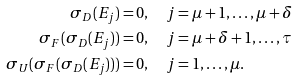<formula> <loc_0><loc_0><loc_500><loc_500>\sigma _ { D } ( E _ { j } ) & = 0 , \quad j = \mu + 1 , \dots , \mu + \delta \\ \sigma _ { F } ( \sigma _ { D } ( E _ { j } ) ) & = 0 , \quad j = \mu + \delta + 1 , \dots , \tau \\ \sigma _ { U } ( \sigma _ { F } ( \sigma _ { D } ( E _ { j } ) ) ) & = 0 , \quad j = 1 , \dots , \mu .</formula> 